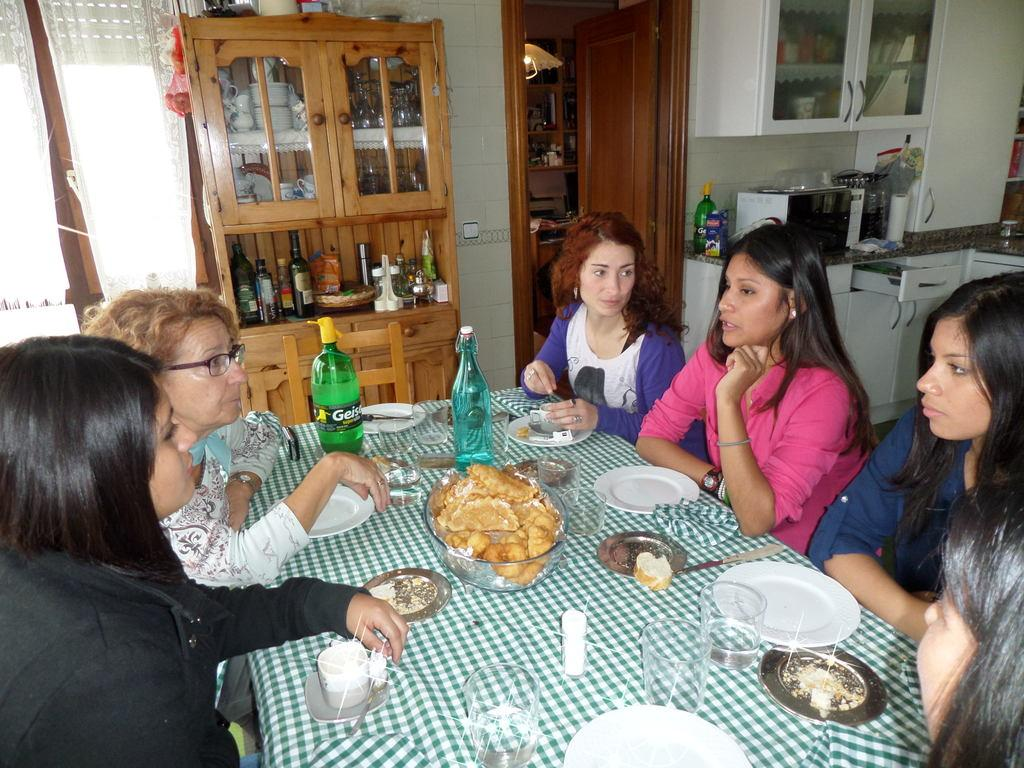What can be seen in the image regarding people? There is a group of ladies in the image. How are the ladies positioned in the image? The ladies are sitting in chairs. What is present in front of the ladies? There is a table in front of the ladies. What is on the table? The table has eatables on it. What appliance can be seen behind the ladies? There is a microwave oven behind the ladies. Can you describe the foggy atmosphere in the image? There is no mention of fog in the image; it does not appear to be present. 